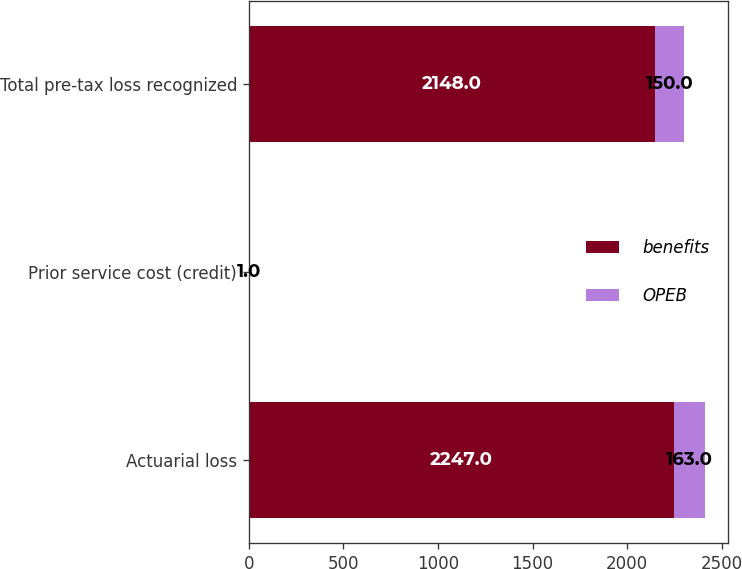<chart> <loc_0><loc_0><loc_500><loc_500><stacked_bar_chart><ecel><fcel>Actuarial loss<fcel>Prior service cost (credit)<fcel>Total pre-tax loss recognized<nl><fcel>benefits<fcel>2247<fcel>1<fcel>2148<nl><fcel>OPEB<fcel>163<fcel>1<fcel>150<nl></chart> 